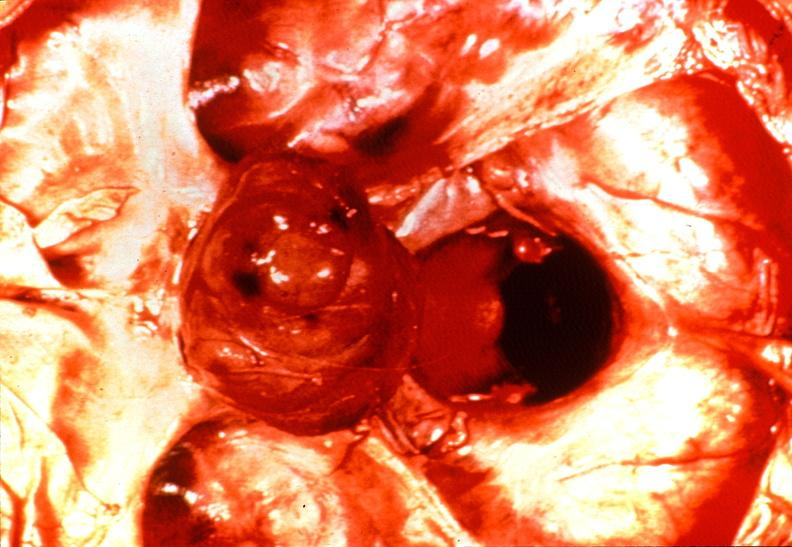what is present?
Answer the question using a single word or phrase. Endocrine 